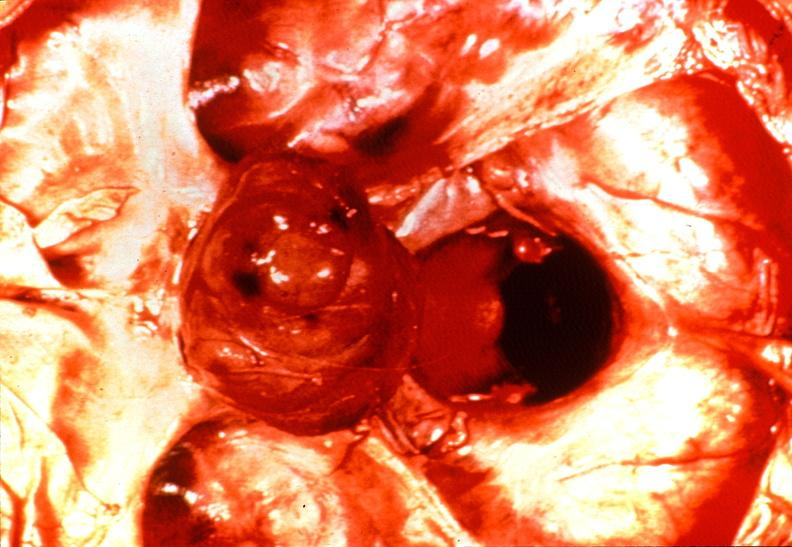what is present?
Answer the question using a single word or phrase. Endocrine 